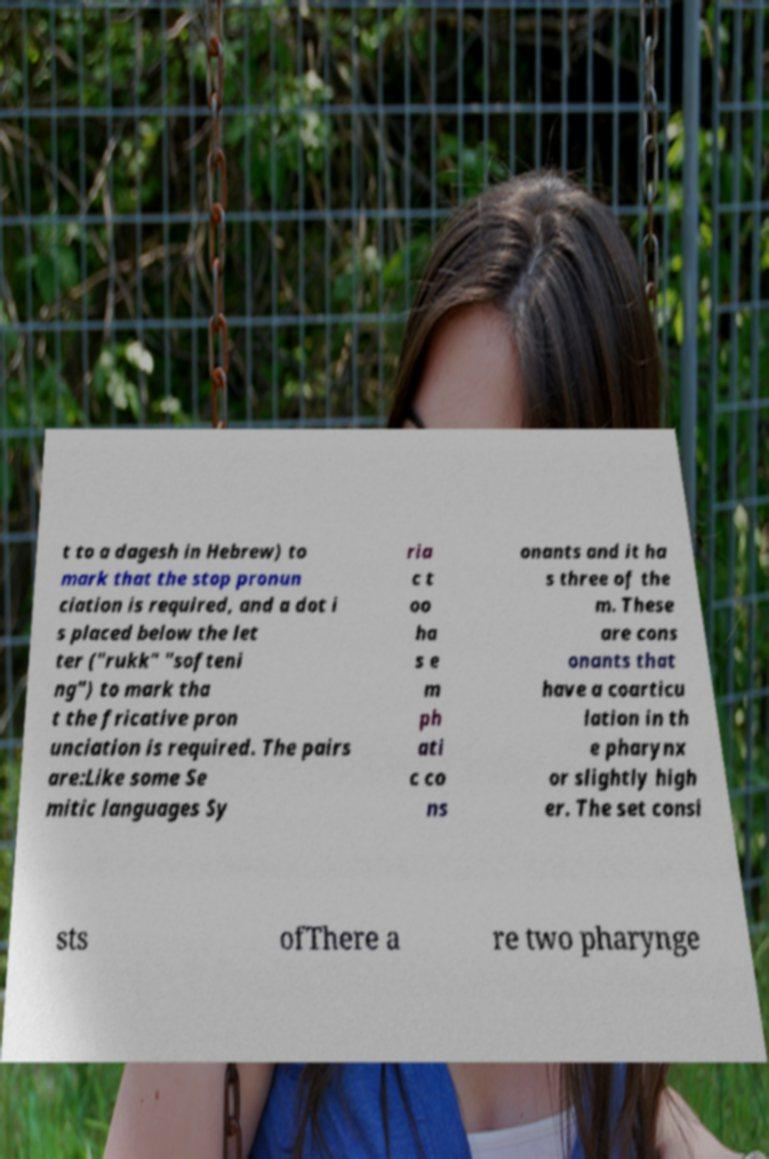Can you read and provide the text displayed in the image?This photo seems to have some interesting text. Can you extract and type it out for me? t to a dagesh in Hebrew) to mark that the stop pronun ciation is required, and a dot i s placed below the let ter ("rukk" "softeni ng") to mark tha t the fricative pron unciation is required. The pairs are:Like some Se mitic languages Sy ria c t oo ha s e m ph ati c co ns onants and it ha s three of the m. These are cons onants that have a coarticu lation in th e pharynx or slightly high er. The set consi sts ofThere a re two pharynge 